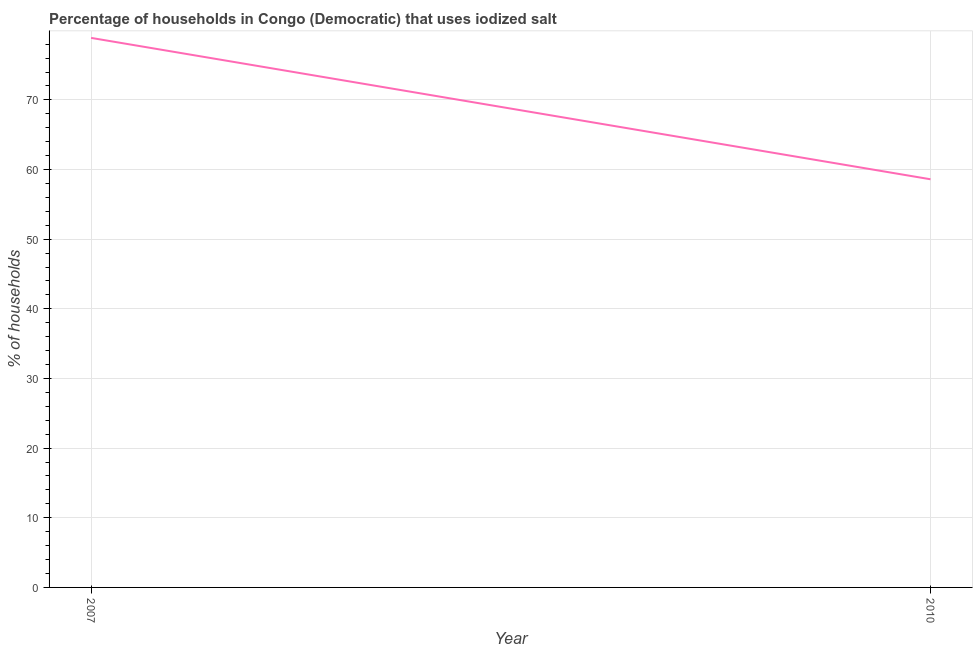What is the percentage of households where iodized salt is consumed in 2010?
Give a very brief answer. 58.6. Across all years, what is the maximum percentage of households where iodized salt is consumed?
Provide a succinct answer. 78.9. Across all years, what is the minimum percentage of households where iodized salt is consumed?
Make the answer very short. 58.6. In which year was the percentage of households where iodized salt is consumed minimum?
Offer a terse response. 2010. What is the sum of the percentage of households where iodized salt is consumed?
Keep it short and to the point. 137.5. What is the difference between the percentage of households where iodized salt is consumed in 2007 and 2010?
Make the answer very short. 20.3. What is the average percentage of households where iodized salt is consumed per year?
Offer a very short reply. 68.75. What is the median percentage of households where iodized salt is consumed?
Provide a short and direct response. 68.75. Do a majority of the years between 2010 and 2007 (inclusive) have percentage of households where iodized salt is consumed greater than 38 %?
Make the answer very short. No. What is the ratio of the percentage of households where iodized salt is consumed in 2007 to that in 2010?
Make the answer very short. 1.35. Is the percentage of households where iodized salt is consumed in 2007 less than that in 2010?
Offer a very short reply. No. In how many years, is the percentage of households where iodized salt is consumed greater than the average percentage of households where iodized salt is consumed taken over all years?
Your answer should be compact. 1. Does the percentage of households where iodized salt is consumed monotonically increase over the years?
Keep it short and to the point. No. How many years are there in the graph?
Your answer should be very brief. 2. What is the difference between two consecutive major ticks on the Y-axis?
Your response must be concise. 10. Are the values on the major ticks of Y-axis written in scientific E-notation?
Offer a very short reply. No. Does the graph contain any zero values?
Ensure brevity in your answer.  No. Does the graph contain grids?
Keep it short and to the point. Yes. What is the title of the graph?
Your response must be concise. Percentage of households in Congo (Democratic) that uses iodized salt. What is the label or title of the X-axis?
Your answer should be very brief. Year. What is the label or title of the Y-axis?
Give a very brief answer. % of households. What is the % of households in 2007?
Ensure brevity in your answer.  78.9. What is the % of households in 2010?
Offer a very short reply. 58.6. What is the difference between the % of households in 2007 and 2010?
Offer a terse response. 20.3. What is the ratio of the % of households in 2007 to that in 2010?
Provide a succinct answer. 1.35. 